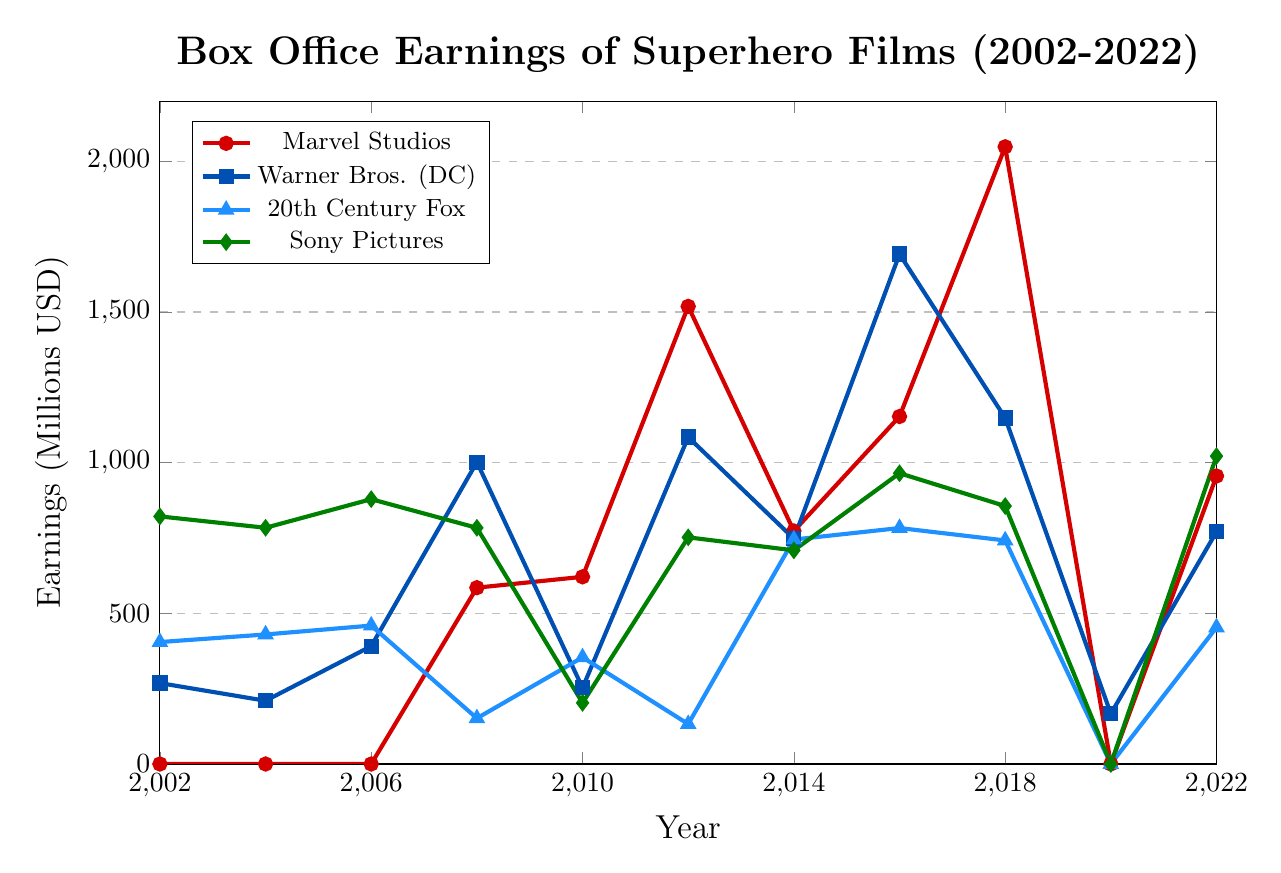what year did Marvel Studios first appear in the box office earnings chart? The chart indicates the earnings of Marvel Studios with a red line, starting from zero in 2002 and 2004. Marvel Studios had its first recorded earnings in 2008.
Answer: 2008 Which studio had the highest box office earnings in 2018? Looking at the lines for 2018 on the plot, Marvel Studios (red line) reached the highest point with box office earnings of around 2048.4 million USD.
Answer: Marvel Studios What is the difference in box office earnings between Marvel Studios and Warner Bros. (DC) in 2012? Marvel Studios earned approximately 1518.8 million USD, while Warner Bros. (DC) earned around 1084.9 million USD in 2012. The difference is 1518.8 - 1084.9 = 433.9 million USD.
Answer: 433.9 million USD During which year did 20th Century Fox have its lowest recorded box office earnings, and what was the amount? The blue line representing 20th Century Fox reaches its lowest point in 2020 with earnings of 0 million USD.
Answer: 2020, 0 million USD Which studio had a significant drop in box office earnings in 2020 compared to the previous years, and what could be the approximate reason? All the studios show a significant drop in 2020, but Marvel Studios (red line) had zero earnings in 2020 after a peak in 2018, potentially due to the COVID-19 pandemic affecting film releases.
Answer: Marvel Studios, COVID-19 pandemic What were the box office earnings for Sony Pictures in 2002, and how does this compare to its earnings in 2022? Sony Pictures earned approximately 821.7 million USD in 2002, and around 1021.8 million USD in 2022. The difference is 1021.8 - 821.7 = 200.1 million USD, showing an increase.
Answer: 821.7 million USD in 2002, 1021.8 million USD in 2022 In which year did all studios except Disney's Marvel Studios show zero box office earnings? In 2020, all studios' earnings drop to zero. Marvel Studios is the only studio that has zero earnings in this year, while others showed low or no earnings.
Answer: 2020 How did the box office earnings trend for Warner Bros. (DC) change from 2014 to 2016? The box office earnings for Warner Bros. (DC) increased from around 747.9 million USD in 2014 to approximately 1692.3 million USD in 2016, indicating a significant rise.
Answer: Increased significantly What is the average box office earnings of Marvel Studios in 2014, 2016, and 2018? The box office earnings for Marvel Studios in these years are: 2014 (773.3 million USD), 2016 (1153.3 million USD), and 2018 (2048.4 million USD). The average is (773.3 + 1153.3 + 2048.4) / 3 = 1331.67 million USD.
Answer: 1331.67 million USD Compare the earnings trends of 20th Century Fox and Sony Pictures from 2010 to 2016. Which studio showed more growth? From 2010, 20th Century Fox earnings grew from 353.9 million USD to 783.1 million USD in 2016, an increase of 429.2 million USD. Sony Pictures' earnings grew from 202.9 million USD in 2010 to 965.0 million USD in 2016, an increase of 762.1 million USD. Therefore, Sony Pictures showed more growth during this period.
Answer: Sony Pictures 